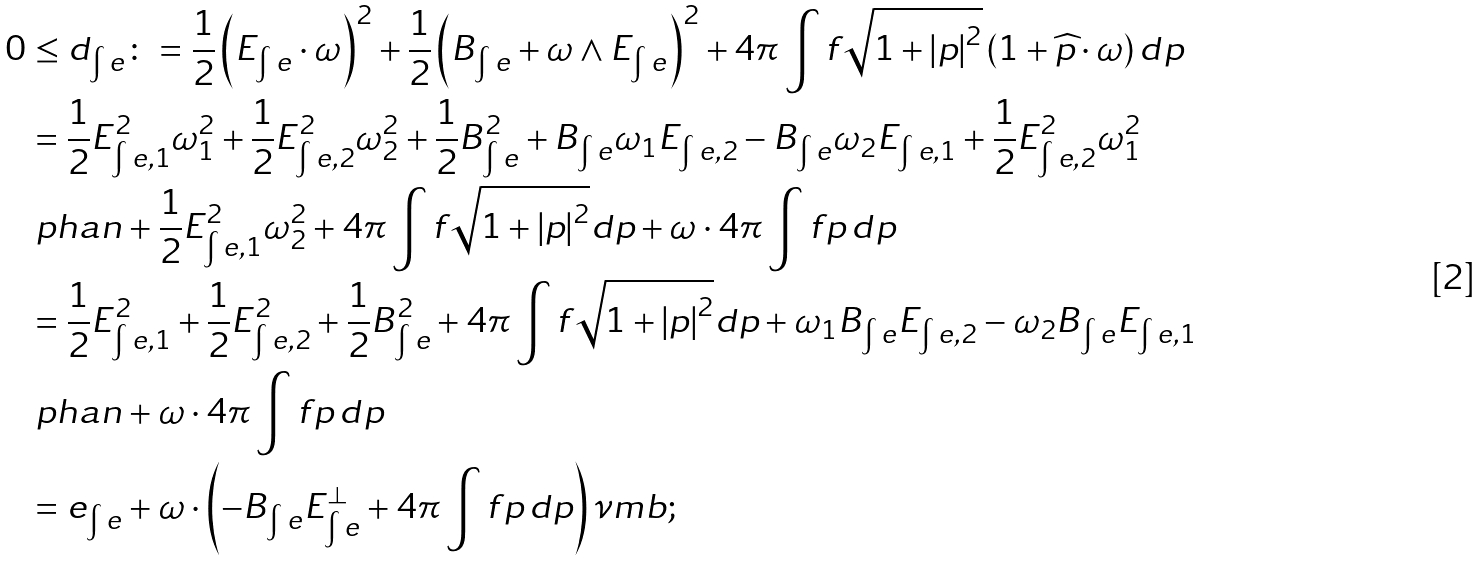Convert formula to latex. <formula><loc_0><loc_0><loc_500><loc_500>0 & \leq d _ { \int e } \colon = \frac { 1 } { 2 } \left ( E _ { \int e } \cdot \omega \right ) ^ { 2 } + \frac { 1 } { 2 } \left ( B _ { \int e } + \omega \wedge E _ { \int e } \right ) ^ { 2 } + 4 \pi \int { f \sqrt { 1 + \left | p \right | ^ { 2 } } \left ( 1 + \widehat { p } \cdot \omega \right ) d p } \\ & = \frac { 1 } { 2 } E _ { \int e , 1 } ^ { 2 } \omega _ { 1 } ^ { 2 } + \frac { 1 } { 2 } E _ { \int e , 2 } ^ { 2 } \omega _ { 2 } ^ { 2 } + \frac { 1 } { 2 } B _ { \int e } ^ { 2 } + B _ { \int e } \omega _ { 1 } E _ { \int e , 2 } - B _ { \int e } \omega _ { 2 } E _ { \int e , 1 } + \frac { 1 } { 2 } E _ { \int e , 2 } ^ { 2 } \omega _ { 1 } ^ { 2 } \\ & \ p h a n + \frac { 1 } { 2 } E _ { \int e , 1 } ^ { 2 } \omega _ { 2 } ^ { 2 } + 4 \pi \int { f \sqrt { 1 + \left | p \right | ^ { 2 } } d p } + \omega \cdot 4 \pi \int { f p \, d p } \\ & = \frac { 1 } { 2 } E _ { \int e , 1 } ^ { 2 } + \frac { 1 } { 2 } E _ { \int e , 2 } ^ { 2 } + \frac { 1 } { 2 } B _ { \int e } ^ { 2 } + 4 \pi \int { f \sqrt { 1 + \left | p \right | ^ { 2 } } d p } + \omega _ { 1 } B _ { \int e } E _ { \int e , 2 } - \omega _ { 2 } B _ { \int e } E _ { \int e , 1 } \\ & \ p h a n + \omega \cdot 4 \pi \int { f p \, d p } \\ & = e _ { \int e } + \omega \cdot \left ( - B _ { \int e } E _ { \int e } ^ { \bot } + 4 \pi \int { f p \, d p } \right ) \nu m b ;</formula> 